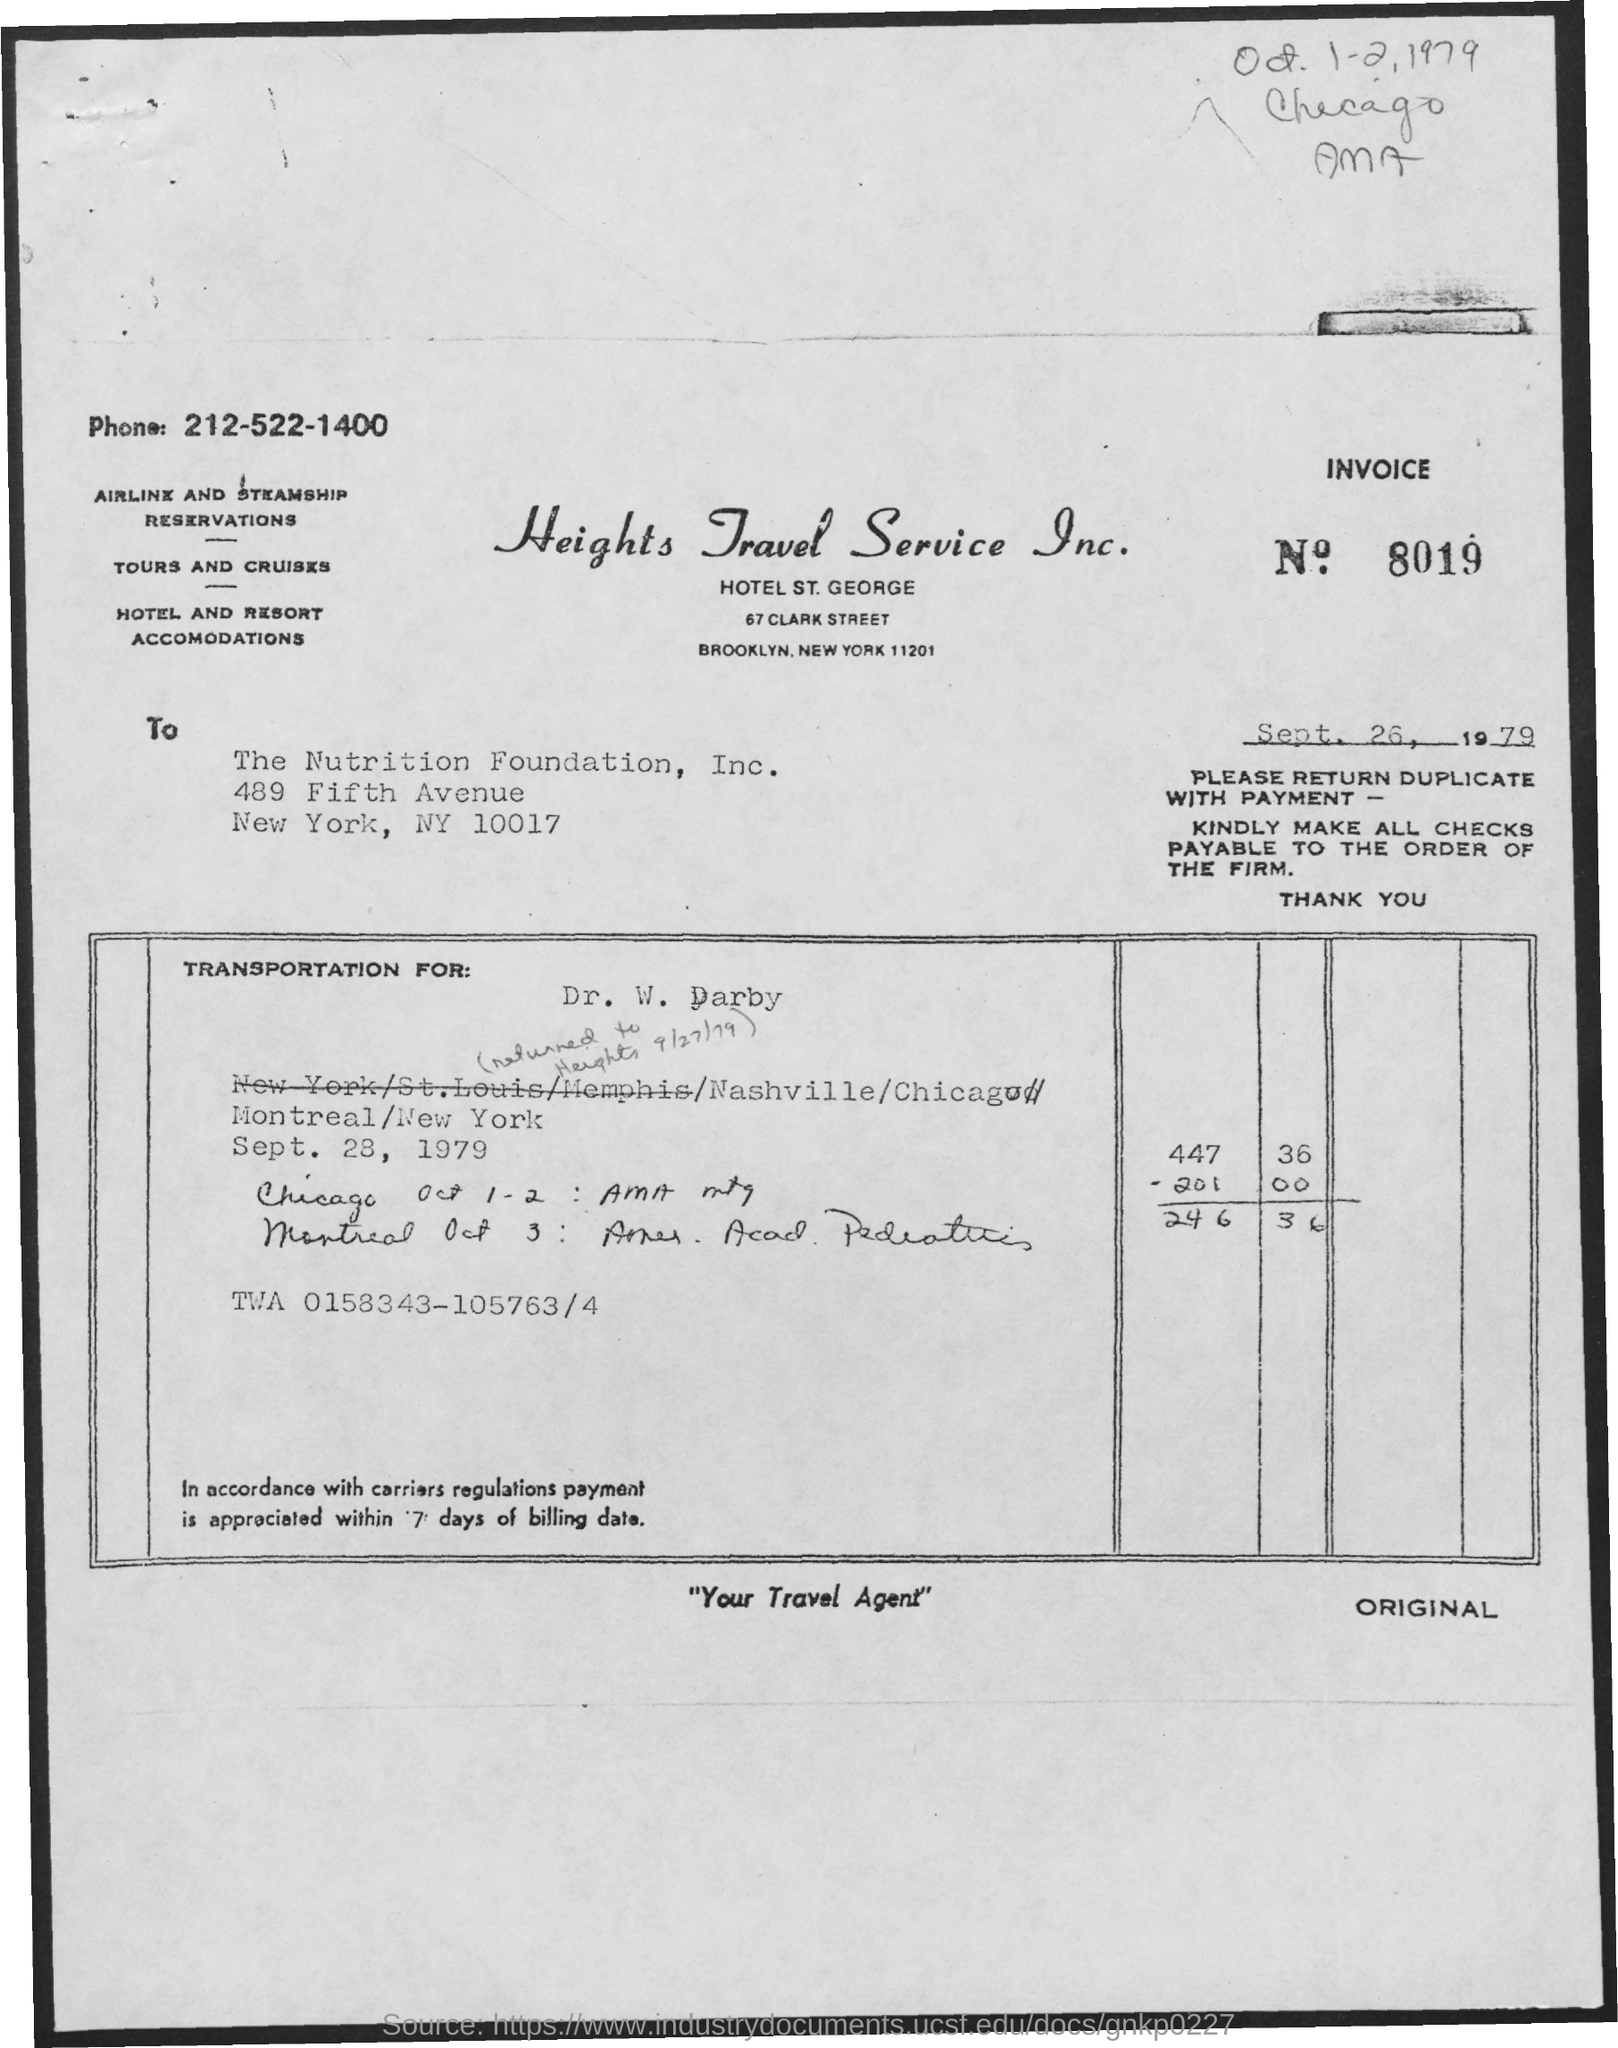What is the Invoice No mentioned in this document?
Make the answer very short. 8019. To whom, the invoice is addressed?
Provide a short and direct response. The Nutrition Foundation, Inc. What is the issued date of the invoice?
Provide a succinct answer. Sept. 26, 1979. 